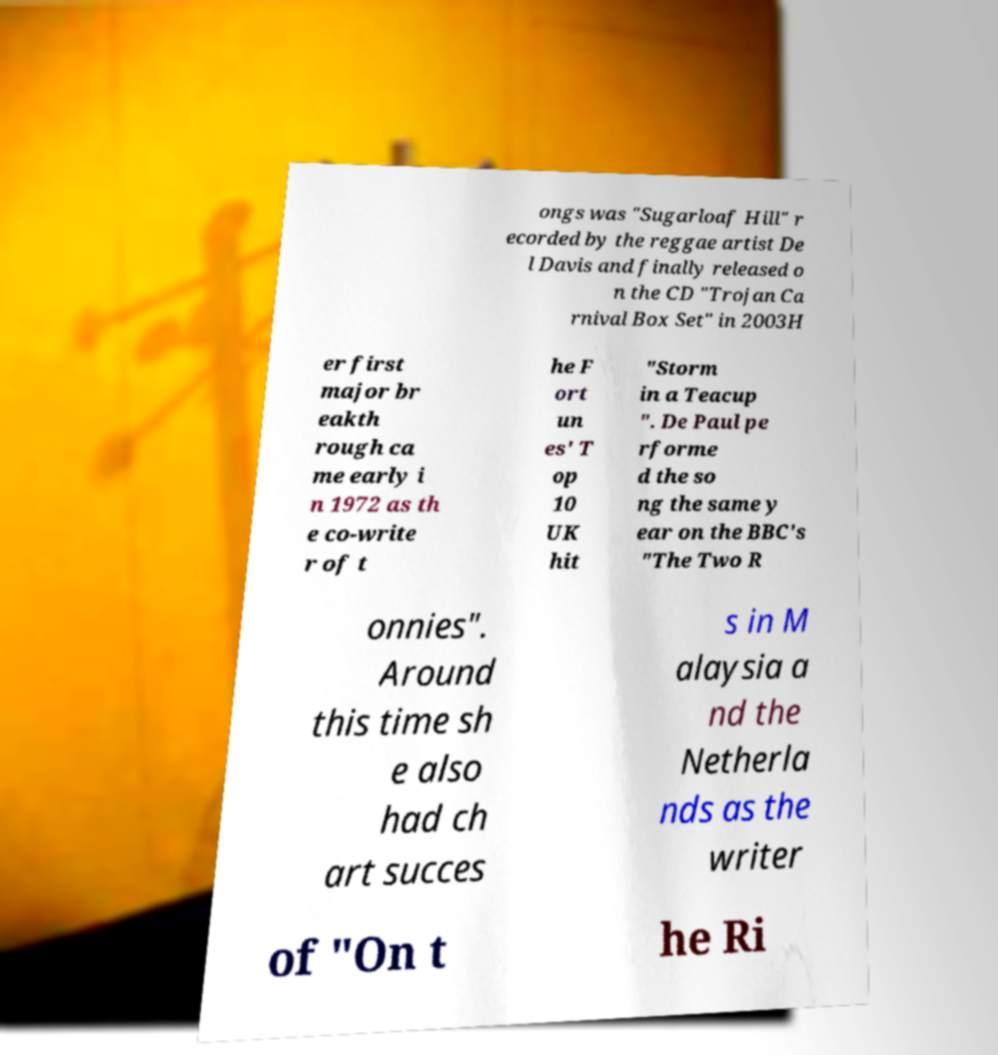Could you assist in decoding the text presented in this image and type it out clearly? ongs was "Sugarloaf Hill" r ecorded by the reggae artist De l Davis and finally released o n the CD "Trojan Ca rnival Box Set" in 2003H er first major br eakth rough ca me early i n 1972 as th e co-write r of t he F ort un es' T op 10 UK hit "Storm in a Teacup ". De Paul pe rforme d the so ng the same y ear on the BBC's "The Two R onnies". Around this time sh e also had ch art succes s in M alaysia a nd the Netherla nds as the writer of "On t he Ri 